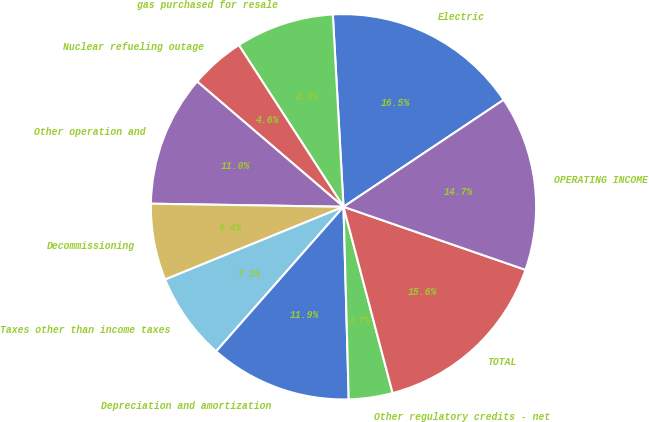Convert chart to OTSL. <chart><loc_0><loc_0><loc_500><loc_500><pie_chart><fcel>Electric<fcel>gas purchased for resale<fcel>Nuclear refueling outage<fcel>Other operation and<fcel>Decommissioning<fcel>Taxes other than income taxes<fcel>Depreciation and amortization<fcel>Other regulatory credits - net<fcel>TOTAL<fcel>OPERATING INCOME<nl><fcel>16.51%<fcel>8.26%<fcel>4.59%<fcel>11.01%<fcel>6.42%<fcel>7.34%<fcel>11.93%<fcel>3.67%<fcel>15.59%<fcel>14.68%<nl></chart> 